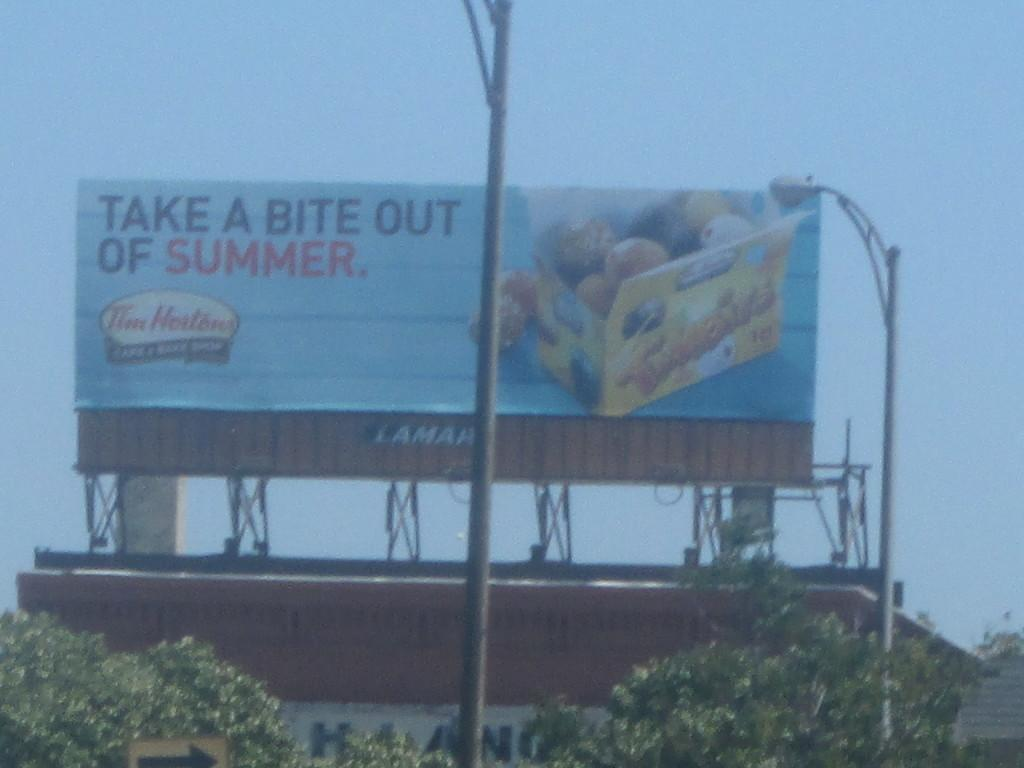<image>
Render a clear and concise summary of the photo. A large billboard says to take a bite out of summer. 